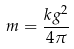Convert formula to latex. <formula><loc_0><loc_0><loc_500><loc_500>m = \frac { k g ^ { 2 } } { 4 \pi }</formula> 